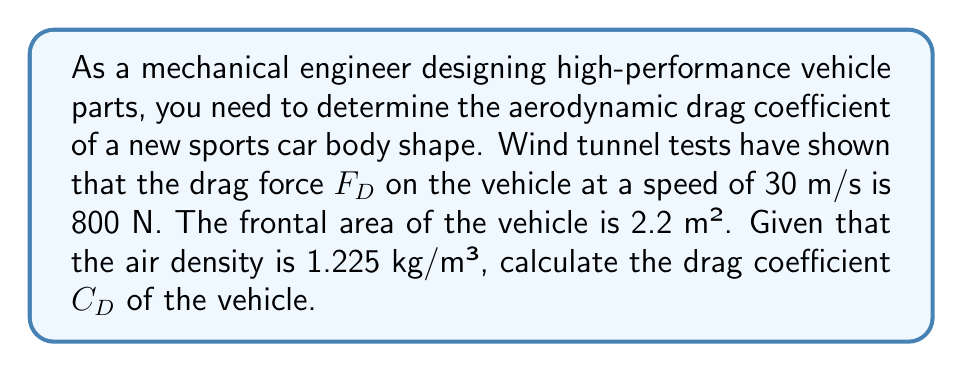What is the answer to this math problem? To solve this problem, we'll use the drag equation:

$$F_D = \frac{1}{2} \rho v^2 C_D A$$

Where:
- $F_D$ is the drag force (N)
- $\rho$ is the air density (kg/m³)
- $v$ is the vehicle speed (m/s)
- $C_D$ is the drag coefficient (dimensionless)
- $A$ is the frontal area of the vehicle (m²)

We know:
- $F_D = 800$ N
- $\rho = 1.225$ kg/m³
- $v = 30$ m/s
- $A = 2.2$ m²

Let's rearrange the equation to solve for $C_D$:

$$C_D = \frac{2F_D}{\rho v^2 A}$$

Now, let's substitute the known values:

$$C_D = \frac{2 \cdot 800}{1.225 \cdot 30^2 \cdot 2.2}$$

Calculating step by step:
1. $30^2 = 900$
2. $1.225 \cdot 900 = 1102.5$
3. $1102.5 \cdot 2.2 = 2425.5$
4. $2 \cdot 800 = 1600$
5. $1600 \div 2425.5 \approx 0.6596$

Therefore, the drag coefficient $C_D$ is approximately 0.3298.
Answer: $C_D \approx 0.3298$ 